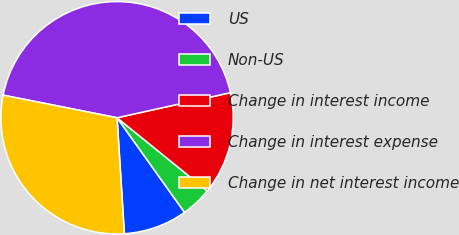<chart> <loc_0><loc_0><loc_500><loc_500><pie_chart><fcel>US<fcel>Non-US<fcel>Change in interest income<fcel>Change in interest expense<fcel>Change in net interest income<nl><fcel>8.86%<fcel>4.3%<fcel>14.31%<fcel>43.42%<fcel>29.12%<nl></chart> 